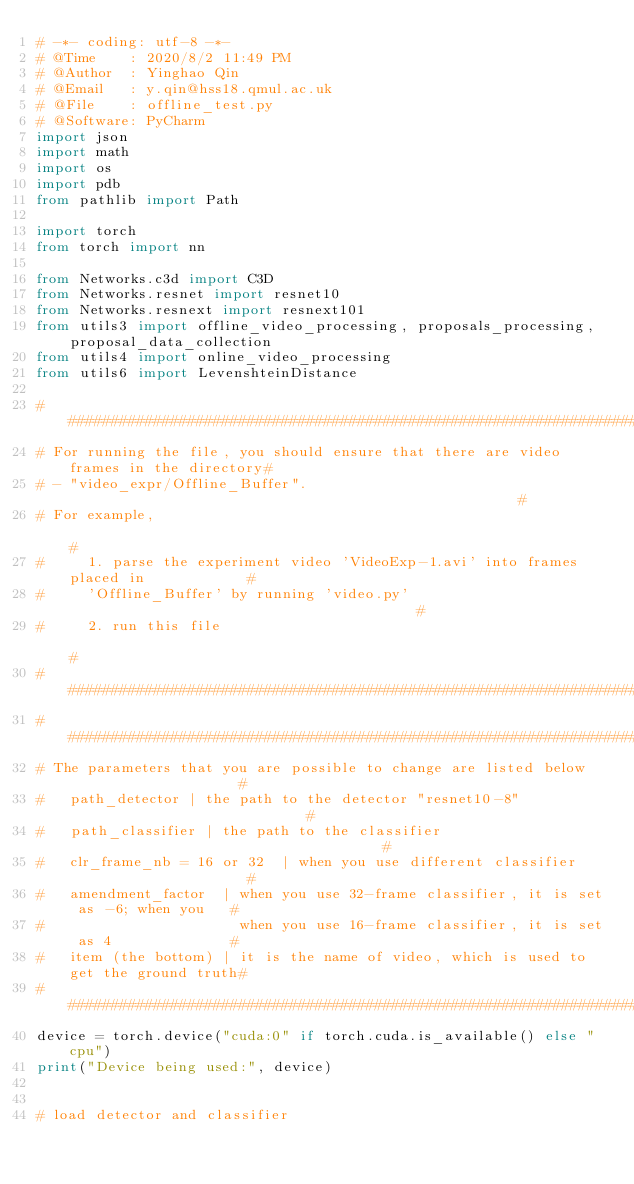Convert code to text. <code><loc_0><loc_0><loc_500><loc_500><_Python_># -*- coding: utf-8 -*-
# @Time    : 2020/8/2 11:49 PM
# @Author  : Yinghao Qin
# @Email   : y.qin@hss18.qmul.ac.uk
# @File    : offline_test.py
# @Software: PyCharm
import json
import math
import os
import pdb
from pathlib import Path

import torch
from torch import nn

from Networks.c3d import C3D
from Networks.resnet import resnet10
from Networks.resnext import resnext101
from utils3 import offline_video_processing, proposals_processing, proposal_data_collection
from utils4 import online_video_processing
from utils6 import LevenshteinDistance

#######################################################################################
# For running the file, you should ensure that there are video frames in the directory#
# - "video_expr/Offline_Buffer".                                                      #
# For example,                                                                        #
#     1. parse the experiment video 'VideoExp-1.avi' into frames placed in            #
#     'Offline_Buffer' by running 'video.py'                                          #
#     2. run this file                                                                #
#######################################################################################
#######################################################################################
# The parameters that you are possible to change are listed below                     #
#   path_detector | the path to the detector "resnet10-8"                             #
#   path_classifier | the path to the classifier                                      #
#   clr_frame_nb = 16 or 32  | when you use different classifier                      #
#   amendment_factor  | when you use 32-frame classifier, it is set as -6; when you   #
#                       when you use 16-frame classifier, it is set as 4              #
#   item (the bottom) | it is the name of video, which is used to get the ground truth#
#######################################################################################
device = torch.device("cuda:0" if torch.cuda.is_available() else "cpu")
print("Device being used:", device)


# load detector and classifier</code> 